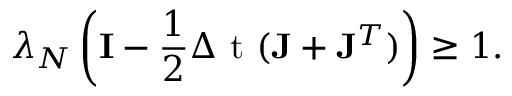<formula> <loc_0><loc_0><loc_500><loc_500>\lambda _ { { N } } \left ( { I } - \frac { 1 } { 2 } { \Delta t } ( { J } + { J } ^ { T } ) \right ) \geq 1 .</formula> 